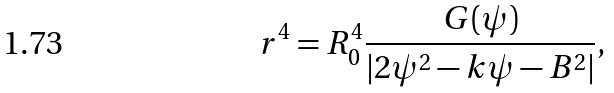Convert formula to latex. <formula><loc_0><loc_0><loc_500><loc_500>r ^ { 4 } = R _ { 0 } ^ { 4 } \frac { G ( \psi ) } { | 2 \psi ^ { 2 } - k \psi - B ^ { 2 } | } ,</formula> 